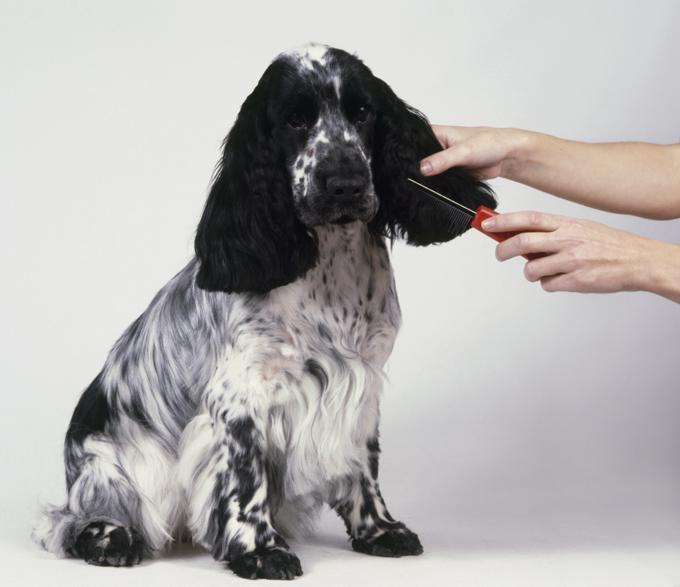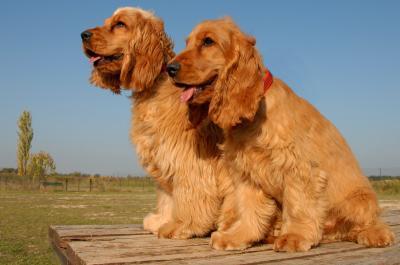The first image is the image on the left, the second image is the image on the right. Considering the images on both sides, is "There are multiple dogs in the right image and they are all the same color." valid? Answer yes or no. Yes. The first image is the image on the left, the second image is the image on the right. Evaluate the accuracy of this statement regarding the images: "Some of the dogs are shown outside.". Is it true? Answer yes or no. Yes. 